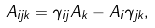Convert formula to latex. <formula><loc_0><loc_0><loc_500><loc_500>A _ { i j k } = \gamma _ { i j } A _ { k } - A _ { i } \gamma _ { j k } ,</formula> 